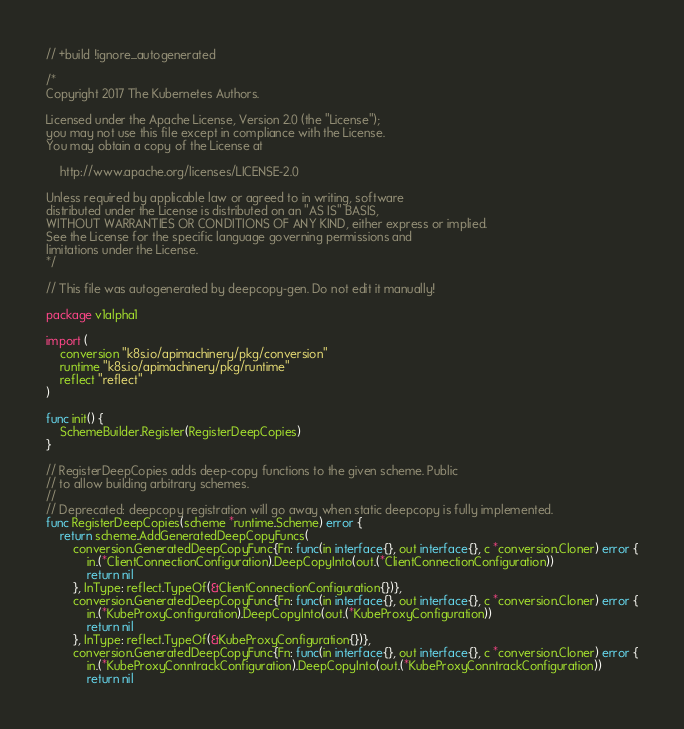Convert code to text. <code><loc_0><loc_0><loc_500><loc_500><_Go_>// +build !ignore_autogenerated

/*
Copyright 2017 The Kubernetes Authors.

Licensed under the Apache License, Version 2.0 (the "License");
you may not use this file except in compliance with the License.
You may obtain a copy of the License at

    http://www.apache.org/licenses/LICENSE-2.0

Unless required by applicable law or agreed to in writing, software
distributed under the License is distributed on an "AS IS" BASIS,
WITHOUT WARRANTIES OR CONDITIONS OF ANY KIND, either express or implied.
See the License for the specific language governing permissions and
limitations under the License.
*/

// This file was autogenerated by deepcopy-gen. Do not edit it manually!

package v1alpha1

import (
	conversion "k8s.io/apimachinery/pkg/conversion"
	runtime "k8s.io/apimachinery/pkg/runtime"
	reflect "reflect"
)

func init() {
	SchemeBuilder.Register(RegisterDeepCopies)
}

// RegisterDeepCopies adds deep-copy functions to the given scheme. Public
// to allow building arbitrary schemes.
//
// Deprecated: deepcopy registration will go away when static deepcopy is fully implemented.
func RegisterDeepCopies(scheme *runtime.Scheme) error {
	return scheme.AddGeneratedDeepCopyFuncs(
		conversion.GeneratedDeepCopyFunc{Fn: func(in interface{}, out interface{}, c *conversion.Cloner) error {
			in.(*ClientConnectionConfiguration).DeepCopyInto(out.(*ClientConnectionConfiguration))
			return nil
		}, InType: reflect.TypeOf(&ClientConnectionConfiguration{})},
		conversion.GeneratedDeepCopyFunc{Fn: func(in interface{}, out interface{}, c *conversion.Cloner) error {
			in.(*KubeProxyConfiguration).DeepCopyInto(out.(*KubeProxyConfiguration))
			return nil
		}, InType: reflect.TypeOf(&KubeProxyConfiguration{})},
		conversion.GeneratedDeepCopyFunc{Fn: func(in interface{}, out interface{}, c *conversion.Cloner) error {
			in.(*KubeProxyConntrackConfiguration).DeepCopyInto(out.(*KubeProxyConntrackConfiguration))
			return nil</code> 